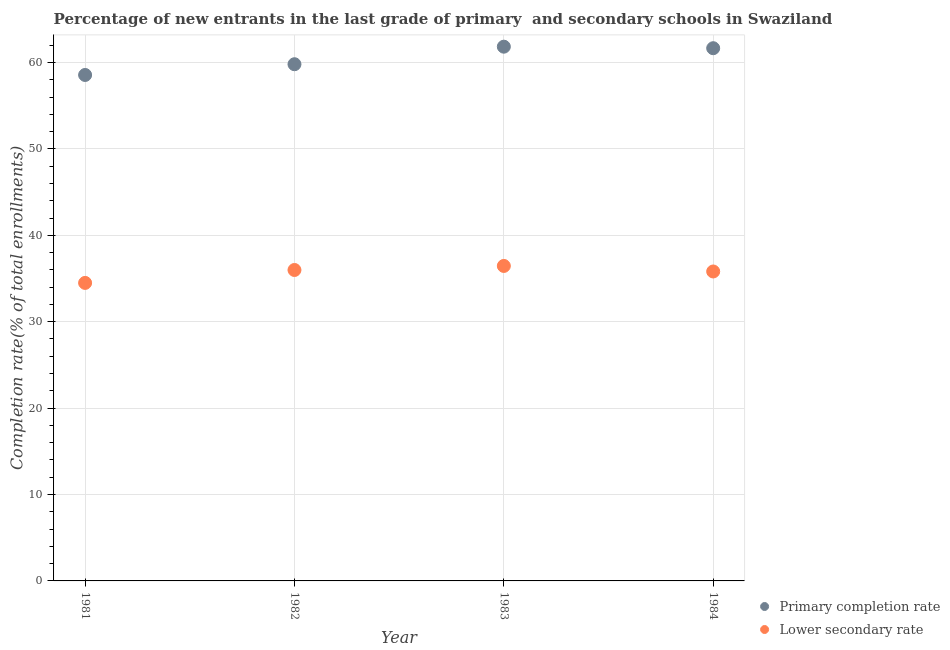Is the number of dotlines equal to the number of legend labels?
Your response must be concise. Yes. What is the completion rate in primary schools in 1982?
Your answer should be very brief. 59.8. Across all years, what is the maximum completion rate in primary schools?
Ensure brevity in your answer.  61.83. Across all years, what is the minimum completion rate in secondary schools?
Your answer should be compact. 34.49. In which year was the completion rate in primary schools minimum?
Your answer should be compact. 1981. What is the total completion rate in primary schools in the graph?
Your response must be concise. 241.84. What is the difference between the completion rate in primary schools in 1983 and that in 1984?
Provide a succinct answer. 0.18. What is the difference between the completion rate in secondary schools in 1981 and the completion rate in primary schools in 1983?
Your answer should be very brief. -27.34. What is the average completion rate in primary schools per year?
Your answer should be compact. 60.46. In the year 1984, what is the difference between the completion rate in secondary schools and completion rate in primary schools?
Your answer should be compact. -25.84. In how many years, is the completion rate in primary schools greater than 8 %?
Make the answer very short. 4. What is the ratio of the completion rate in primary schools in 1981 to that in 1982?
Your answer should be compact. 0.98. What is the difference between the highest and the second highest completion rate in secondary schools?
Provide a short and direct response. 0.47. What is the difference between the highest and the lowest completion rate in secondary schools?
Your response must be concise. 1.96. Is the completion rate in primary schools strictly greater than the completion rate in secondary schools over the years?
Provide a short and direct response. Yes. Is the completion rate in secondary schools strictly less than the completion rate in primary schools over the years?
Offer a terse response. Yes. How many dotlines are there?
Provide a succinct answer. 2. How many years are there in the graph?
Offer a terse response. 4. Are the values on the major ticks of Y-axis written in scientific E-notation?
Offer a terse response. No. Does the graph contain any zero values?
Make the answer very short. No. Where does the legend appear in the graph?
Ensure brevity in your answer.  Bottom right. How many legend labels are there?
Make the answer very short. 2. What is the title of the graph?
Provide a short and direct response. Percentage of new entrants in the last grade of primary  and secondary schools in Swaziland. Does "Unregistered firms" appear as one of the legend labels in the graph?
Offer a terse response. No. What is the label or title of the X-axis?
Make the answer very short. Year. What is the label or title of the Y-axis?
Ensure brevity in your answer.  Completion rate(% of total enrollments). What is the Completion rate(% of total enrollments) in Primary completion rate in 1981?
Offer a very short reply. 58.56. What is the Completion rate(% of total enrollments) of Lower secondary rate in 1981?
Make the answer very short. 34.49. What is the Completion rate(% of total enrollments) of Primary completion rate in 1982?
Ensure brevity in your answer.  59.8. What is the Completion rate(% of total enrollments) in Lower secondary rate in 1982?
Your response must be concise. 35.99. What is the Completion rate(% of total enrollments) of Primary completion rate in 1983?
Offer a very short reply. 61.83. What is the Completion rate(% of total enrollments) in Lower secondary rate in 1983?
Provide a short and direct response. 36.45. What is the Completion rate(% of total enrollments) of Primary completion rate in 1984?
Your response must be concise. 61.65. What is the Completion rate(% of total enrollments) in Lower secondary rate in 1984?
Provide a short and direct response. 35.81. Across all years, what is the maximum Completion rate(% of total enrollments) of Primary completion rate?
Your response must be concise. 61.83. Across all years, what is the maximum Completion rate(% of total enrollments) in Lower secondary rate?
Ensure brevity in your answer.  36.45. Across all years, what is the minimum Completion rate(% of total enrollments) of Primary completion rate?
Provide a succinct answer. 58.56. Across all years, what is the minimum Completion rate(% of total enrollments) of Lower secondary rate?
Provide a succinct answer. 34.49. What is the total Completion rate(% of total enrollments) of Primary completion rate in the graph?
Give a very brief answer. 241.84. What is the total Completion rate(% of total enrollments) of Lower secondary rate in the graph?
Your response must be concise. 142.75. What is the difference between the Completion rate(% of total enrollments) of Primary completion rate in 1981 and that in 1982?
Your answer should be very brief. -1.24. What is the difference between the Completion rate(% of total enrollments) in Lower secondary rate in 1981 and that in 1982?
Offer a terse response. -1.5. What is the difference between the Completion rate(% of total enrollments) of Primary completion rate in 1981 and that in 1983?
Keep it short and to the point. -3.27. What is the difference between the Completion rate(% of total enrollments) in Lower secondary rate in 1981 and that in 1983?
Keep it short and to the point. -1.96. What is the difference between the Completion rate(% of total enrollments) in Primary completion rate in 1981 and that in 1984?
Your answer should be very brief. -3.1. What is the difference between the Completion rate(% of total enrollments) in Lower secondary rate in 1981 and that in 1984?
Give a very brief answer. -1.32. What is the difference between the Completion rate(% of total enrollments) of Primary completion rate in 1982 and that in 1983?
Your response must be concise. -2.03. What is the difference between the Completion rate(% of total enrollments) of Lower secondary rate in 1982 and that in 1983?
Offer a very short reply. -0.47. What is the difference between the Completion rate(% of total enrollments) in Primary completion rate in 1982 and that in 1984?
Offer a very short reply. -1.85. What is the difference between the Completion rate(% of total enrollments) in Lower secondary rate in 1982 and that in 1984?
Provide a succinct answer. 0.17. What is the difference between the Completion rate(% of total enrollments) of Primary completion rate in 1983 and that in 1984?
Provide a succinct answer. 0.18. What is the difference between the Completion rate(% of total enrollments) of Lower secondary rate in 1983 and that in 1984?
Provide a succinct answer. 0.64. What is the difference between the Completion rate(% of total enrollments) of Primary completion rate in 1981 and the Completion rate(% of total enrollments) of Lower secondary rate in 1982?
Your response must be concise. 22.57. What is the difference between the Completion rate(% of total enrollments) of Primary completion rate in 1981 and the Completion rate(% of total enrollments) of Lower secondary rate in 1983?
Ensure brevity in your answer.  22.1. What is the difference between the Completion rate(% of total enrollments) of Primary completion rate in 1981 and the Completion rate(% of total enrollments) of Lower secondary rate in 1984?
Offer a very short reply. 22.74. What is the difference between the Completion rate(% of total enrollments) of Primary completion rate in 1982 and the Completion rate(% of total enrollments) of Lower secondary rate in 1983?
Your answer should be compact. 23.35. What is the difference between the Completion rate(% of total enrollments) of Primary completion rate in 1982 and the Completion rate(% of total enrollments) of Lower secondary rate in 1984?
Provide a succinct answer. 23.99. What is the difference between the Completion rate(% of total enrollments) in Primary completion rate in 1983 and the Completion rate(% of total enrollments) in Lower secondary rate in 1984?
Your response must be concise. 26.02. What is the average Completion rate(% of total enrollments) in Primary completion rate per year?
Your answer should be very brief. 60.46. What is the average Completion rate(% of total enrollments) in Lower secondary rate per year?
Make the answer very short. 35.69. In the year 1981, what is the difference between the Completion rate(% of total enrollments) in Primary completion rate and Completion rate(% of total enrollments) in Lower secondary rate?
Provide a short and direct response. 24.07. In the year 1982, what is the difference between the Completion rate(% of total enrollments) of Primary completion rate and Completion rate(% of total enrollments) of Lower secondary rate?
Provide a succinct answer. 23.81. In the year 1983, what is the difference between the Completion rate(% of total enrollments) of Primary completion rate and Completion rate(% of total enrollments) of Lower secondary rate?
Your answer should be very brief. 25.38. In the year 1984, what is the difference between the Completion rate(% of total enrollments) of Primary completion rate and Completion rate(% of total enrollments) of Lower secondary rate?
Your answer should be very brief. 25.84. What is the ratio of the Completion rate(% of total enrollments) in Primary completion rate in 1981 to that in 1982?
Your answer should be very brief. 0.98. What is the ratio of the Completion rate(% of total enrollments) of Lower secondary rate in 1981 to that in 1982?
Offer a terse response. 0.96. What is the ratio of the Completion rate(% of total enrollments) in Primary completion rate in 1981 to that in 1983?
Ensure brevity in your answer.  0.95. What is the ratio of the Completion rate(% of total enrollments) of Lower secondary rate in 1981 to that in 1983?
Keep it short and to the point. 0.95. What is the ratio of the Completion rate(% of total enrollments) in Primary completion rate in 1981 to that in 1984?
Provide a short and direct response. 0.95. What is the ratio of the Completion rate(% of total enrollments) in Lower secondary rate in 1981 to that in 1984?
Your answer should be very brief. 0.96. What is the ratio of the Completion rate(% of total enrollments) of Primary completion rate in 1982 to that in 1983?
Make the answer very short. 0.97. What is the ratio of the Completion rate(% of total enrollments) of Lower secondary rate in 1982 to that in 1983?
Provide a succinct answer. 0.99. What is the ratio of the Completion rate(% of total enrollments) in Primary completion rate in 1982 to that in 1984?
Your response must be concise. 0.97. What is the ratio of the Completion rate(% of total enrollments) in Lower secondary rate in 1982 to that in 1984?
Keep it short and to the point. 1. What is the ratio of the Completion rate(% of total enrollments) of Lower secondary rate in 1983 to that in 1984?
Your answer should be very brief. 1.02. What is the difference between the highest and the second highest Completion rate(% of total enrollments) of Primary completion rate?
Offer a very short reply. 0.18. What is the difference between the highest and the second highest Completion rate(% of total enrollments) of Lower secondary rate?
Give a very brief answer. 0.47. What is the difference between the highest and the lowest Completion rate(% of total enrollments) of Primary completion rate?
Offer a very short reply. 3.27. What is the difference between the highest and the lowest Completion rate(% of total enrollments) in Lower secondary rate?
Make the answer very short. 1.96. 